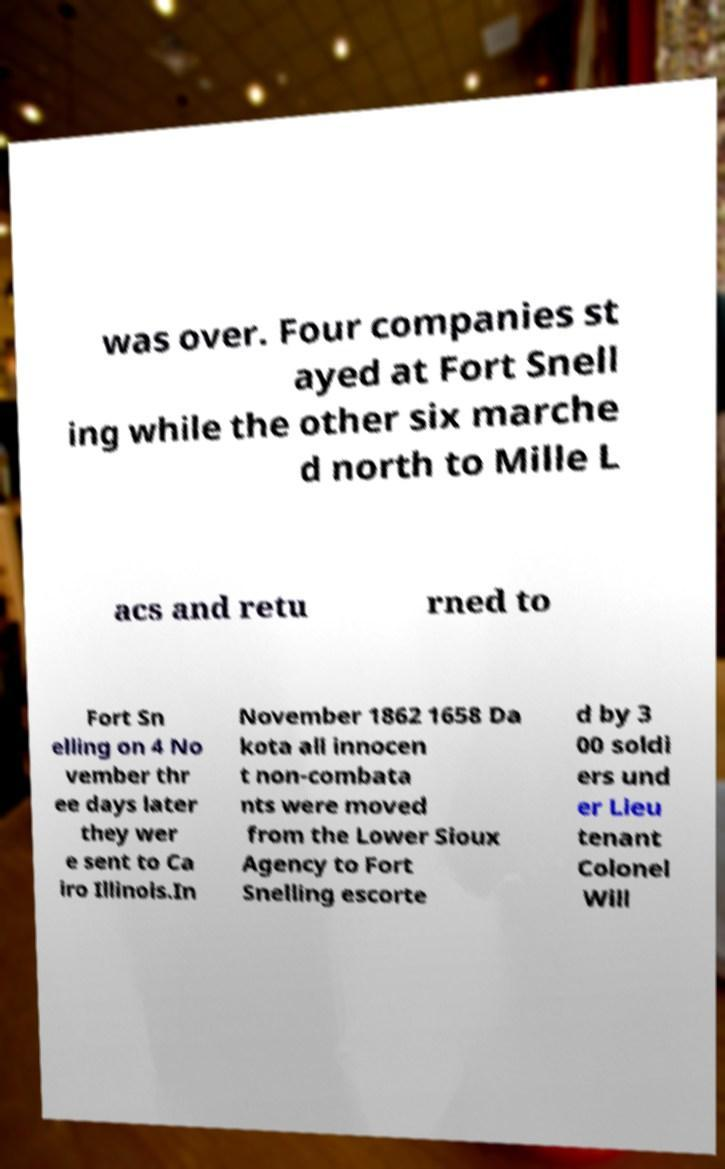Could you extract and type out the text from this image? was over. Four companies st ayed at Fort Snell ing while the other six marche d north to Mille L acs and retu rned to Fort Sn elling on 4 No vember thr ee days later they wer e sent to Ca iro Illinois.In November 1862 1658 Da kota all innocen t non-combata nts were moved from the Lower Sioux Agency to Fort Snelling escorte d by 3 00 soldi ers und er Lieu tenant Colonel Will 